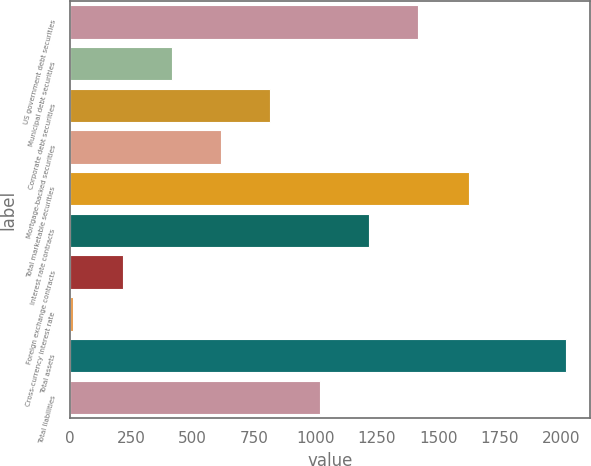Convert chart. <chart><loc_0><loc_0><loc_500><loc_500><bar_chart><fcel>US government debt securities<fcel>Municipal debt securities<fcel>Corporate debt securities<fcel>Mortgage-backed securities<fcel>Total marketable securities<fcel>Interest rate contracts<fcel>Foreign exchange contracts<fcel>Cross-currency interest rate<fcel>Total assets<fcel>Total liabilities<nl><fcel>1417.8<fcel>415.8<fcel>816.6<fcel>616.2<fcel>1625<fcel>1217.4<fcel>215.4<fcel>15<fcel>2019<fcel>1017<nl></chart> 